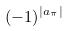<formula> <loc_0><loc_0><loc_500><loc_500>( - 1 ) ^ { | a _ { \pi } | }</formula> 